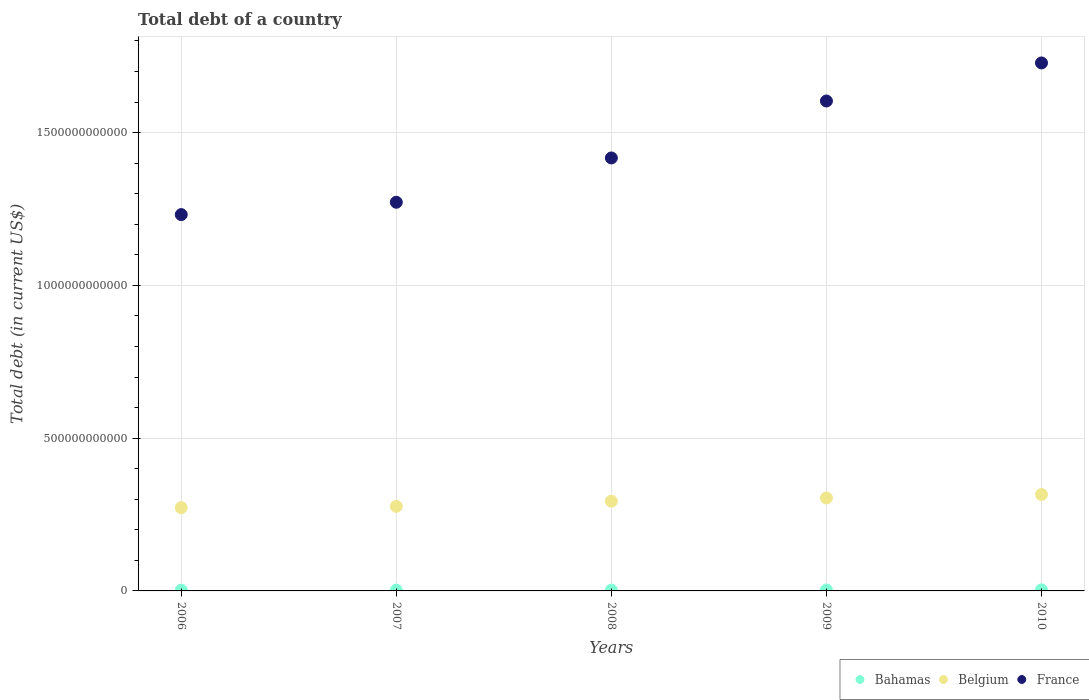How many different coloured dotlines are there?
Your answer should be compact. 3. Is the number of dotlines equal to the number of legend labels?
Your response must be concise. Yes. What is the debt in Bahamas in 2006?
Ensure brevity in your answer.  2.39e+09. Across all years, what is the maximum debt in Belgium?
Make the answer very short. 3.15e+11. Across all years, what is the minimum debt in Bahamas?
Provide a short and direct response. 2.39e+09. What is the total debt in France in the graph?
Keep it short and to the point. 7.25e+12. What is the difference between the debt in Belgium in 2007 and that in 2009?
Ensure brevity in your answer.  -2.75e+1. What is the difference between the debt in Bahamas in 2006 and the debt in Belgium in 2007?
Provide a short and direct response. -2.74e+11. What is the average debt in Bahamas per year?
Your answer should be compact. 2.80e+09. In the year 2006, what is the difference between the debt in France and debt in Bahamas?
Give a very brief answer. 1.23e+12. What is the ratio of the debt in France in 2006 to that in 2010?
Your response must be concise. 0.71. Is the debt in France in 2006 less than that in 2010?
Give a very brief answer. Yes. Is the difference between the debt in France in 2007 and 2010 greater than the difference between the debt in Bahamas in 2007 and 2010?
Give a very brief answer. No. What is the difference between the highest and the second highest debt in Belgium?
Offer a very short reply. 1.12e+1. What is the difference between the highest and the lowest debt in Belgium?
Give a very brief answer. 4.30e+1. In how many years, is the debt in France greater than the average debt in France taken over all years?
Give a very brief answer. 2. Is the sum of the debt in France in 2006 and 2008 greater than the maximum debt in Belgium across all years?
Offer a very short reply. Yes. Is it the case that in every year, the sum of the debt in Bahamas and debt in France  is greater than the debt in Belgium?
Make the answer very short. Yes. Is the debt in Bahamas strictly greater than the debt in Belgium over the years?
Ensure brevity in your answer.  No. Is the debt in Belgium strictly less than the debt in Bahamas over the years?
Keep it short and to the point. No. What is the difference between two consecutive major ticks on the Y-axis?
Keep it short and to the point. 5.00e+11. Does the graph contain grids?
Offer a very short reply. Yes. Where does the legend appear in the graph?
Provide a succinct answer. Bottom right. How many legend labels are there?
Provide a short and direct response. 3. What is the title of the graph?
Your answer should be compact. Total debt of a country. What is the label or title of the X-axis?
Your answer should be compact. Years. What is the label or title of the Y-axis?
Give a very brief answer. Total debt (in current US$). What is the Total debt (in current US$) of Bahamas in 2006?
Provide a short and direct response. 2.39e+09. What is the Total debt (in current US$) of Belgium in 2006?
Your answer should be compact. 2.72e+11. What is the Total debt (in current US$) of France in 2006?
Provide a short and direct response. 1.23e+12. What is the Total debt (in current US$) in Bahamas in 2007?
Your answer should be compact. 2.47e+09. What is the Total debt (in current US$) in Belgium in 2007?
Offer a terse response. 2.77e+11. What is the Total debt (in current US$) of France in 2007?
Provide a succinct answer. 1.27e+12. What is the Total debt (in current US$) of Bahamas in 2008?
Your answer should be compact. 2.68e+09. What is the Total debt (in current US$) of Belgium in 2008?
Provide a short and direct response. 2.94e+11. What is the Total debt (in current US$) of France in 2008?
Ensure brevity in your answer.  1.42e+12. What is the Total debt (in current US$) of Bahamas in 2009?
Your answer should be compact. 3.08e+09. What is the Total debt (in current US$) of Belgium in 2009?
Offer a very short reply. 3.04e+11. What is the Total debt (in current US$) in France in 2009?
Give a very brief answer. 1.60e+12. What is the Total debt (in current US$) of Bahamas in 2010?
Give a very brief answer. 3.40e+09. What is the Total debt (in current US$) in Belgium in 2010?
Keep it short and to the point. 3.15e+11. What is the Total debt (in current US$) in France in 2010?
Keep it short and to the point. 1.73e+12. Across all years, what is the maximum Total debt (in current US$) of Bahamas?
Offer a very short reply. 3.40e+09. Across all years, what is the maximum Total debt (in current US$) of Belgium?
Your response must be concise. 3.15e+11. Across all years, what is the maximum Total debt (in current US$) in France?
Provide a succinct answer. 1.73e+12. Across all years, what is the minimum Total debt (in current US$) of Bahamas?
Your response must be concise. 2.39e+09. Across all years, what is the minimum Total debt (in current US$) in Belgium?
Your answer should be compact. 2.72e+11. Across all years, what is the minimum Total debt (in current US$) in France?
Provide a succinct answer. 1.23e+12. What is the total Total debt (in current US$) in Bahamas in the graph?
Provide a succinct answer. 1.40e+1. What is the total Total debt (in current US$) of Belgium in the graph?
Give a very brief answer. 1.46e+12. What is the total Total debt (in current US$) in France in the graph?
Provide a succinct answer. 7.25e+12. What is the difference between the Total debt (in current US$) in Bahamas in 2006 and that in 2007?
Offer a terse response. -8.30e+07. What is the difference between the Total debt (in current US$) of Belgium in 2006 and that in 2007?
Provide a short and direct response. -4.37e+09. What is the difference between the Total debt (in current US$) in France in 2006 and that in 2007?
Offer a terse response. -4.04e+1. What is the difference between the Total debt (in current US$) of Bahamas in 2006 and that in 2008?
Provide a short and direct response. -2.93e+08. What is the difference between the Total debt (in current US$) in Belgium in 2006 and that in 2008?
Provide a succinct answer. -2.12e+1. What is the difference between the Total debt (in current US$) in France in 2006 and that in 2008?
Make the answer very short. -1.85e+11. What is the difference between the Total debt (in current US$) of Bahamas in 2006 and that in 2009?
Your answer should be compact. -6.98e+08. What is the difference between the Total debt (in current US$) in Belgium in 2006 and that in 2009?
Make the answer very short. -3.18e+1. What is the difference between the Total debt (in current US$) in France in 2006 and that in 2009?
Offer a terse response. -3.72e+11. What is the difference between the Total debt (in current US$) of Bahamas in 2006 and that in 2010?
Provide a short and direct response. -1.01e+09. What is the difference between the Total debt (in current US$) in Belgium in 2006 and that in 2010?
Provide a short and direct response. -4.30e+1. What is the difference between the Total debt (in current US$) in France in 2006 and that in 2010?
Your response must be concise. -4.96e+11. What is the difference between the Total debt (in current US$) of Bahamas in 2007 and that in 2008?
Your answer should be compact. -2.10e+08. What is the difference between the Total debt (in current US$) of Belgium in 2007 and that in 2008?
Your answer should be compact. -1.69e+1. What is the difference between the Total debt (in current US$) in France in 2007 and that in 2008?
Give a very brief answer. -1.45e+11. What is the difference between the Total debt (in current US$) of Bahamas in 2007 and that in 2009?
Your response must be concise. -6.15e+08. What is the difference between the Total debt (in current US$) in Belgium in 2007 and that in 2009?
Your response must be concise. -2.75e+1. What is the difference between the Total debt (in current US$) in France in 2007 and that in 2009?
Offer a terse response. -3.31e+11. What is the difference between the Total debt (in current US$) of Bahamas in 2007 and that in 2010?
Your answer should be compact. -9.32e+08. What is the difference between the Total debt (in current US$) of Belgium in 2007 and that in 2010?
Offer a very short reply. -3.86e+1. What is the difference between the Total debt (in current US$) of France in 2007 and that in 2010?
Offer a very short reply. -4.56e+11. What is the difference between the Total debt (in current US$) of Bahamas in 2008 and that in 2009?
Offer a terse response. -4.06e+08. What is the difference between the Total debt (in current US$) in Belgium in 2008 and that in 2009?
Provide a short and direct response. -1.06e+1. What is the difference between the Total debt (in current US$) in France in 2008 and that in 2009?
Ensure brevity in your answer.  -1.86e+11. What is the difference between the Total debt (in current US$) of Bahamas in 2008 and that in 2010?
Give a very brief answer. -7.22e+08. What is the difference between the Total debt (in current US$) of Belgium in 2008 and that in 2010?
Your answer should be very brief. -2.18e+1. What is the difference between the Total debt (in current US$) of France in 2008 and that in 2010?
Your answer should be very brief. -3.11e+11. What is the difference between the Total debt (in current US$) of Bahamas in 2009 and that in 2010?
Offer a terse response. -3.16e+08. What is the difference between the Total debt (in current US$) of Belgium in 2009 and that in 2010?
Your response must be concise. -1.12e+1. What is the difference between the Total debt (in current US$) in France in 2009 and that in 2010?
Your response must be concise. -1.25e+11. What is the difference between the Total debt (in current US$) of Bahamas in 2006 and the Total debt (in current US$) of Belgium in 2007?
Give a very brief answer. -2.74e+11. What is the difference between the Total debt (in current US$) of Bahamas in 2006 and the Total debt (in current US$) of France in 2007?
Your response must be concise. -1.27e+12. What is the difference between the Total debt (in current US$) in Belgium in 2006 and the Total debt (in current US$) in France in 2007?
Your answer should be compact. -1.00e+12. What is the difference between the Total debt (in current US$) in Bahamas in 2006 and the Total debt (in current US$) in Belgium in 2008?
Make the answer very short. -2.91e+11. What is the difference between the Total debt (in current US$) of Bahamas in 2006 and the Total debt (in current US$) of France in 2008?
Ensure brevity in your answer.  -1.41e+12. What is the difference between the Total debt (in current US$) in Belgium in 2006 and the Total debt (in current US$) in France in 2008?
Your answer should be very brief. -1.14e+12. What is the difference between the Total debt (in current US$) of Bahamas in 2006 and the Total debt (in current US$) of Belgium in 2009?
Offer a terse response. -3.02e+11. What is the difference between the Total debt (in current US$) in Bahamas in 2006 and the Total debt (in current US$) in France in 2009?
Offer a terse response. -1.60e+12. What is the difference between the Total debt (in current US$) of Belgium in 2006 and the Total debt (in current US$) of France in 2009?
Your answer should be compact. -1.33e+12. What is the difference between the Total debt (in current US$) of Bahamas in 2006 and the Total debt (in current US$) of Belgium in 2010?
Your answer should be very brief. -3.13e+11. What is the difference between the Total debt (in current US$) in Bahamas in 2006 and the Total debt (in current US$) in France in 2010?
Provide a succinct answer. -1.73e+12. What is the difference between the Total debt (in current US$) of Belgium in 2006 and the Total debt (in current US$) of France in 2010?
Your response must be concise. -1.46e+12. What is the difference between the Total debt (in current US$) of Bahamas in 2007 and the Total debt (in current US$) of Belgium in 2008?
Your response must be concise. -2.91e+11. What is the difference between the Total debt (in current US$) in Bahamas in 2007 and the Total debt (in current US$) in France in 2008?
Offer a very short reply. -1.41e+12. What is the difference between the Total debt (in current US$) in Belgium in 2007 and the Total debt (in current US$) in France in 2008?
Keep it short and to the point. -1.14e+12. What is the difference between the Total debt (in current US$) in Bahamas in 2007 and the Total debt (in current US$) in Belgium in 2009?
Provide a short and direct response. -3.02e+11. What is the difference between the Total debt (in current US$) of Bahamas in 2007 and the Total debt (in current US$) of France in 2009?
Provide a short and direct response. -1.60e+12. What is the difference between the Total debt (in current US$) in Belgium in 2007 and the Total debt (in current US$) in France in 2009?
Provide a short and direct response. -1.33e+12. What is the difference between the Total debt (in current US$) in Bahamas in 2007 and the Total debt (in current US$) in Belgium in 2010?
Offer a terse response. -3.13e+11. What is the difference between the Total debt (in current US$) in Bahamas in 2007 and the Total debt (in current US$) in France in 2010?
Your response must be concise. -1.73e+12. What is the difference between the Total debt (in current US$) in Belgium in 2007 and the Total debt (in current US$) in France in 2010?
Provide a short and direct response. -1.45e+12. What is the difference between the Total debt (in current US$) in Bahamas in 2008 and the Total debt (in current US$) in Belgium in 2009?
Make the answer very short. -3.02e+11. What is the difference between the Total debt (in current US$) in Bahamas in 2008 and the Total debt (in current US$) in France in 2009?
Offer a terse response. -1.60e+12. What is the difference between the Total debt (in current US$) of Belgium in 2008 and the Total debt (in current US$) of France in 2009?
Your response must be concise. -1.31e+12. What is the difference between the Total debt (in current US$) of Bahamas in 2008 and the Total debt (in current US$) of Belgium in 2010?
Make the answer very short. -3.13e+11. What is the difference between the Total debt (in current US$) of Bahamas in 2008 and the Total debt (in current US$) of France in 2010?
Give a very brief answer. -1.73e+12. What is the difference between the Total debt (in current US$) of Belgium in 2008 and the Total debt (in current US$) of France in 2010?
Ensure brevity in your answer.  -1.43e+12. What is the difference between the Total debt (in current US$) of Bahamas in 2009 and the Total debt (in current US$) of Belgium in 2010?
Keep it short and to the point. -3.12e+11. What is the difference between the Total debt (in current US$) in Bahamas in 2009 and the Total debt (in current US$) in France in 2010?
Keep it short and to the point. -1.72e+12. What is the difference between the Total debt (in current US$) in Belgium in 2009 and the Total debt (in current US$) in France in 2010?
Make the answer very short. -1.42e+12. What is the average Total debt (in current US$) of Bahamas per year?
Your answer should be very brief. 2.80e+09. What is the average Total debt (in current US$) in Belgium per year?
Keep it short and to the point. 2.93e+11. What is the average Total debt (in current US$) of France per year?
Your answer should be compact. 1.45e+12. In the year 2006, what is the difference between the Total debt (in current US$) of Bahamas and Total debt (in current US$) of Belgium?
Your answer should be compact. -2.70e+11. In the year 2006, what is the difference between the Total debt (in current US$) in Bahamas and Total debt (in current US$) in France?
Make the answer very short. -1.23e+12. In the year 2006, what is the difference between the Total debt (in current US$) of Belgium and Total debt (in current US$) of France?
Make the answer very short. -9.59e+11. In the year 2007, what is the difference between the Total debt (in current US$) in Bahamas and Total debt (in current US$) in Belgium?
Offer a terse response. -2.74e+11. In the year 2007, what is the difference between the Total debt (in current US$) of Bahamas and Total debt (in current US$) of France?
Your answer should be compact. -1.27e+12. In the year 2007, what is the difference between the Total debt (in current US$) in Belgium and Total debt (in current US$) in France?
Give a very brief answer. -9.95e+11. In the year 2008, what is the difference between the Total debt (in current US$) of Bahamas and Total debt (in current US$) of Belgium?
Make the answer very short. -2.91e+11. In the year 2008, what is the difference between the Total debt (in current US$) in Bahamas and Total debt (in current US$) in France?
Keep it short and to the point. -1.41e+12. In the year 2008, what is the difference between the Total debt (in current US$) of Belgium and Total debt (in current US$) of France?
Give a very brief answer. -1.12e+12. In the year 2009, what is the difference between the Total debt (in current US$) of Bahamas and Total debt (in current US$) of Belgium?
Ensure brevity in your answer.  -3.01e+11. In the year 2009, what is the difference between the Total debt (in current US$) in Bahamas and Total debt (in current US$) in France?
Offer a very short reply. -1.60e+12. In the year 2009, what is the difference between the Total debt (in current US$) in Belgium and Total debt (in current US$) in France?
Offer a terse response. -1.30e+12. In the year 2010, what is the difference between the Total debt (in current US$) in Bahamas and Total debt (in current US$) in Belgium?
Make the answer very short. -3.12e+11. In the year 2010, what is the difference between the Total debt (in current US$) of Bahamas and Total debt (in current US$) of France?
Provide a short and direct response. -1.72e+12. In the year 2010, what is the difference between the Total debt (in current US$) of Belgium and Total debt (in current US$) of France?
Your answer should be compact. -1.41e+12. What is the ratio of the Total debt (in current US$) of Bahamas in 2006 to that in 2007?
Offer a very short reply. 0.97. What is the ratio of the Total debt (in current US$) in Belgium in 2006 to that in 2007?
Give a very brief answer. 0.98. What is the ratio of the Total debt (in current US$) in France in 2006 to that in 2007?
Keep it short and to the point. 0.97. What is the ratio of the Total debt (in current US$) of Bahamas in 2006 to that in 2008?
Keep it short and to the point. 0.89. What is the ratio of the Total debt (in current US$) in Belgium in 2006 to that in 2008?
Make the answer very short. 0.93. What is the ratio of the Total debt (in current US$) of France in 2006 to that in 2008?
Provide a succinct answer. 0.87. What is the ratio of the Total debt (in current US$) of Bahamas in 2006 to that in 2009?
Offer a terse response. 0.77. What is the ratio of the Total debt (in current US$) in Belgium in 2006 to that in 2009?
Ensure brevity in your answer.  0.9. What is the ratio of the Total debt (in current US$) in France in 2006 to that in 2009?
Your response must be concise. 0.77. What is the ratio of the Total debt (in current US$) in Bahamas in 2006 to that in 2010?
Keep it short and to the point. 0.7. What is the ratio of the Total debt (in current US$) in Belgium in 2006 to that in 2010?
Provide a succinct answer. 0.86. What is the ratio of the Total debt (in current US$) in France in 2006 to that in 2010?
Your response must be concise. 0.71. What is the ratio of the Total debt (in current US$) in Bahamas in 2007 to that in 2008?
Provide a succinct answer. 0.92. What is the ratio of the Total debt (in current US$) of Belgium in 2007 to that in 2008?
Provide a short and direct response. 0.94. What is the ratio of the Total debt (in current US$) of France in 2007 to that in 2008?
Provide a short and direct response. 0.9. What is the ratio of the Total debt (in current US$) of Bahamas in 2007 to that in 2009?
Provide a short and direct response. 0.8. What is the ratio of the Total debt (in current US$) in Belgium in 2007 to that in 2009?
Your answer should be very brief. 0.91. What is the ratio of the Total debt (in current US$) of France in 2007 to that in 2009?
Keep it short and to the point. 0.79. What is the ratio of the Total debt (in current US$) of Bahamas in 2007 to that in 2010?
Provide a short and direct response. 0.73. What is the ratio of the Total debt (in current US$) in Belgium in 2007 to that in 2010?
Your response must be concise. 0.88. What is the ratio of the Total debt (in current US$) in France in 2007 to that in 2010?
Your answer should be compact. 0.74. What is the ratio of the Total debt (in current US$) of Bahamas in 2008 to that in 2009?
Your answer should be very brief. 0.87. What is the ratio of the Total debt (in current US$) in Belgium in 2008 to that in 2009?
Provide a succinct answer. 0.97. What is the ratio of the Total debt (in current US$) of France in 2008 to that in 2009?
Make the answer very short. 0.88. What is the ratio of the Total debt (in current US$) of Bahamas in 2008 to that in 2010?
Offer a terse response. 0.79. What is the ratio of the Total debt (in current US$) in France in 2008 to that in 2010?
Provide a short and direct response. 0.82. What is the ratio of the Total debt (in current US$) in Bahamas in 2009 to that in 2010?
Give a very brief answer. 0.91. What is the ratio of the Total debt (in current US$) in Belgium in 2009 to that in 2010?
Provide a short and direct response. 0.96. What is the ratio of the Total debt (in current US$) of France in 2009 to that in 2010?
Offer a terse response. 0.93. What is the difference between the highest and the second highest Total debt (in current US$) of Bahamas?
Your response must be concise. 3.16e+08. What is the difference between the highest and the second highest Total debt (in current US$) of Belgium?
Offer a very short reply. 1.12e+1. What is the difference between the highest and the second highest Total debt (in current US$) in France?
Give a very brief answer. 1.25e+11. What is the difference between the highest and the lowest Total debt (in current US$) in Bahamas?
Offer a terse response. 1.01e+09. What is the difference between the highest and the lowest Total debt (in current US$) in Belgium?
Offer a terse response. 4.30e+1. What is the difference between the highest and the lowest Total debt (in current US$) of France?
Provide a succinct answer. 4.96e+11. 